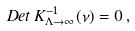Convert formula to latex. <formula><loc_0><loc_0><loc_500><loc_500>D e t \, K _ { \Lambda \to \infty } ^ { - 1 } ( \nu ) = 0 \, ,</formula> 